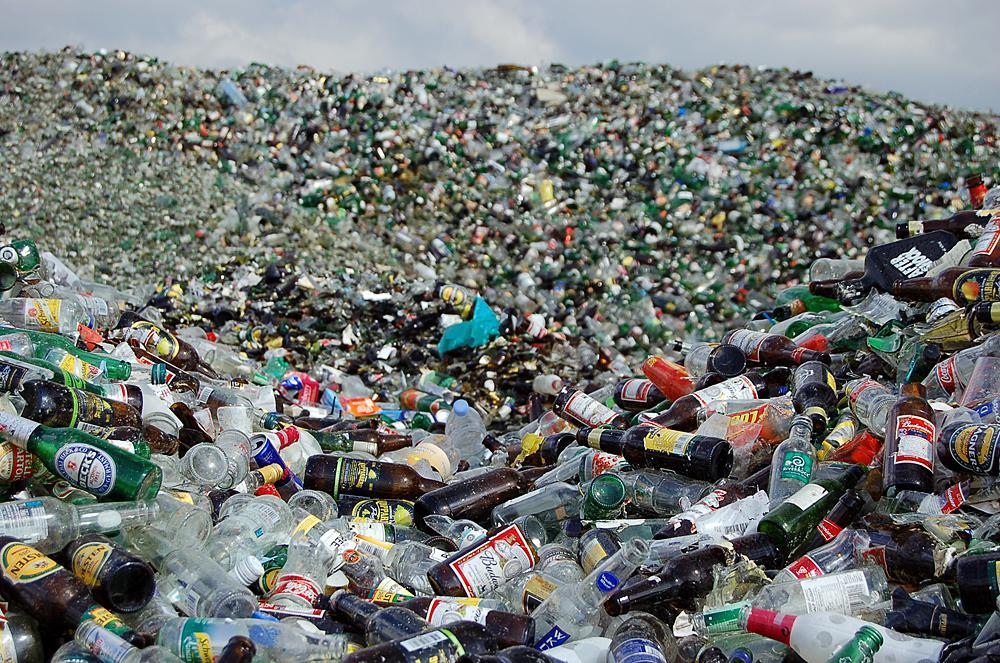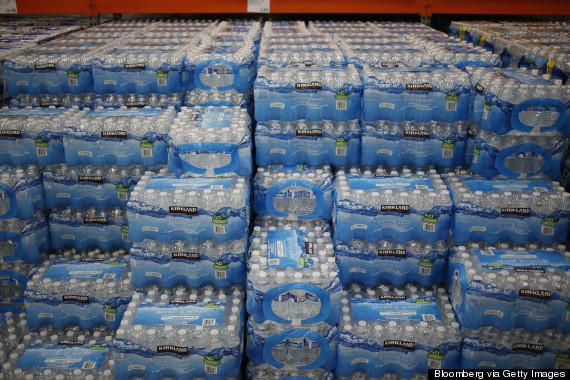The first image is the image on the left, the second image is the image on the right. Examine the images to the left and right. Is the description "One image shows water bottles in multiple tiers." accurate? Answer yes or no. Yes. The first image is the image on the left, the second image is the image on the right. Assess this claim about the two images: "At least one image contains small water bottles arranged in neat rows.". Correct or not? Answer yes or no. Yes. 